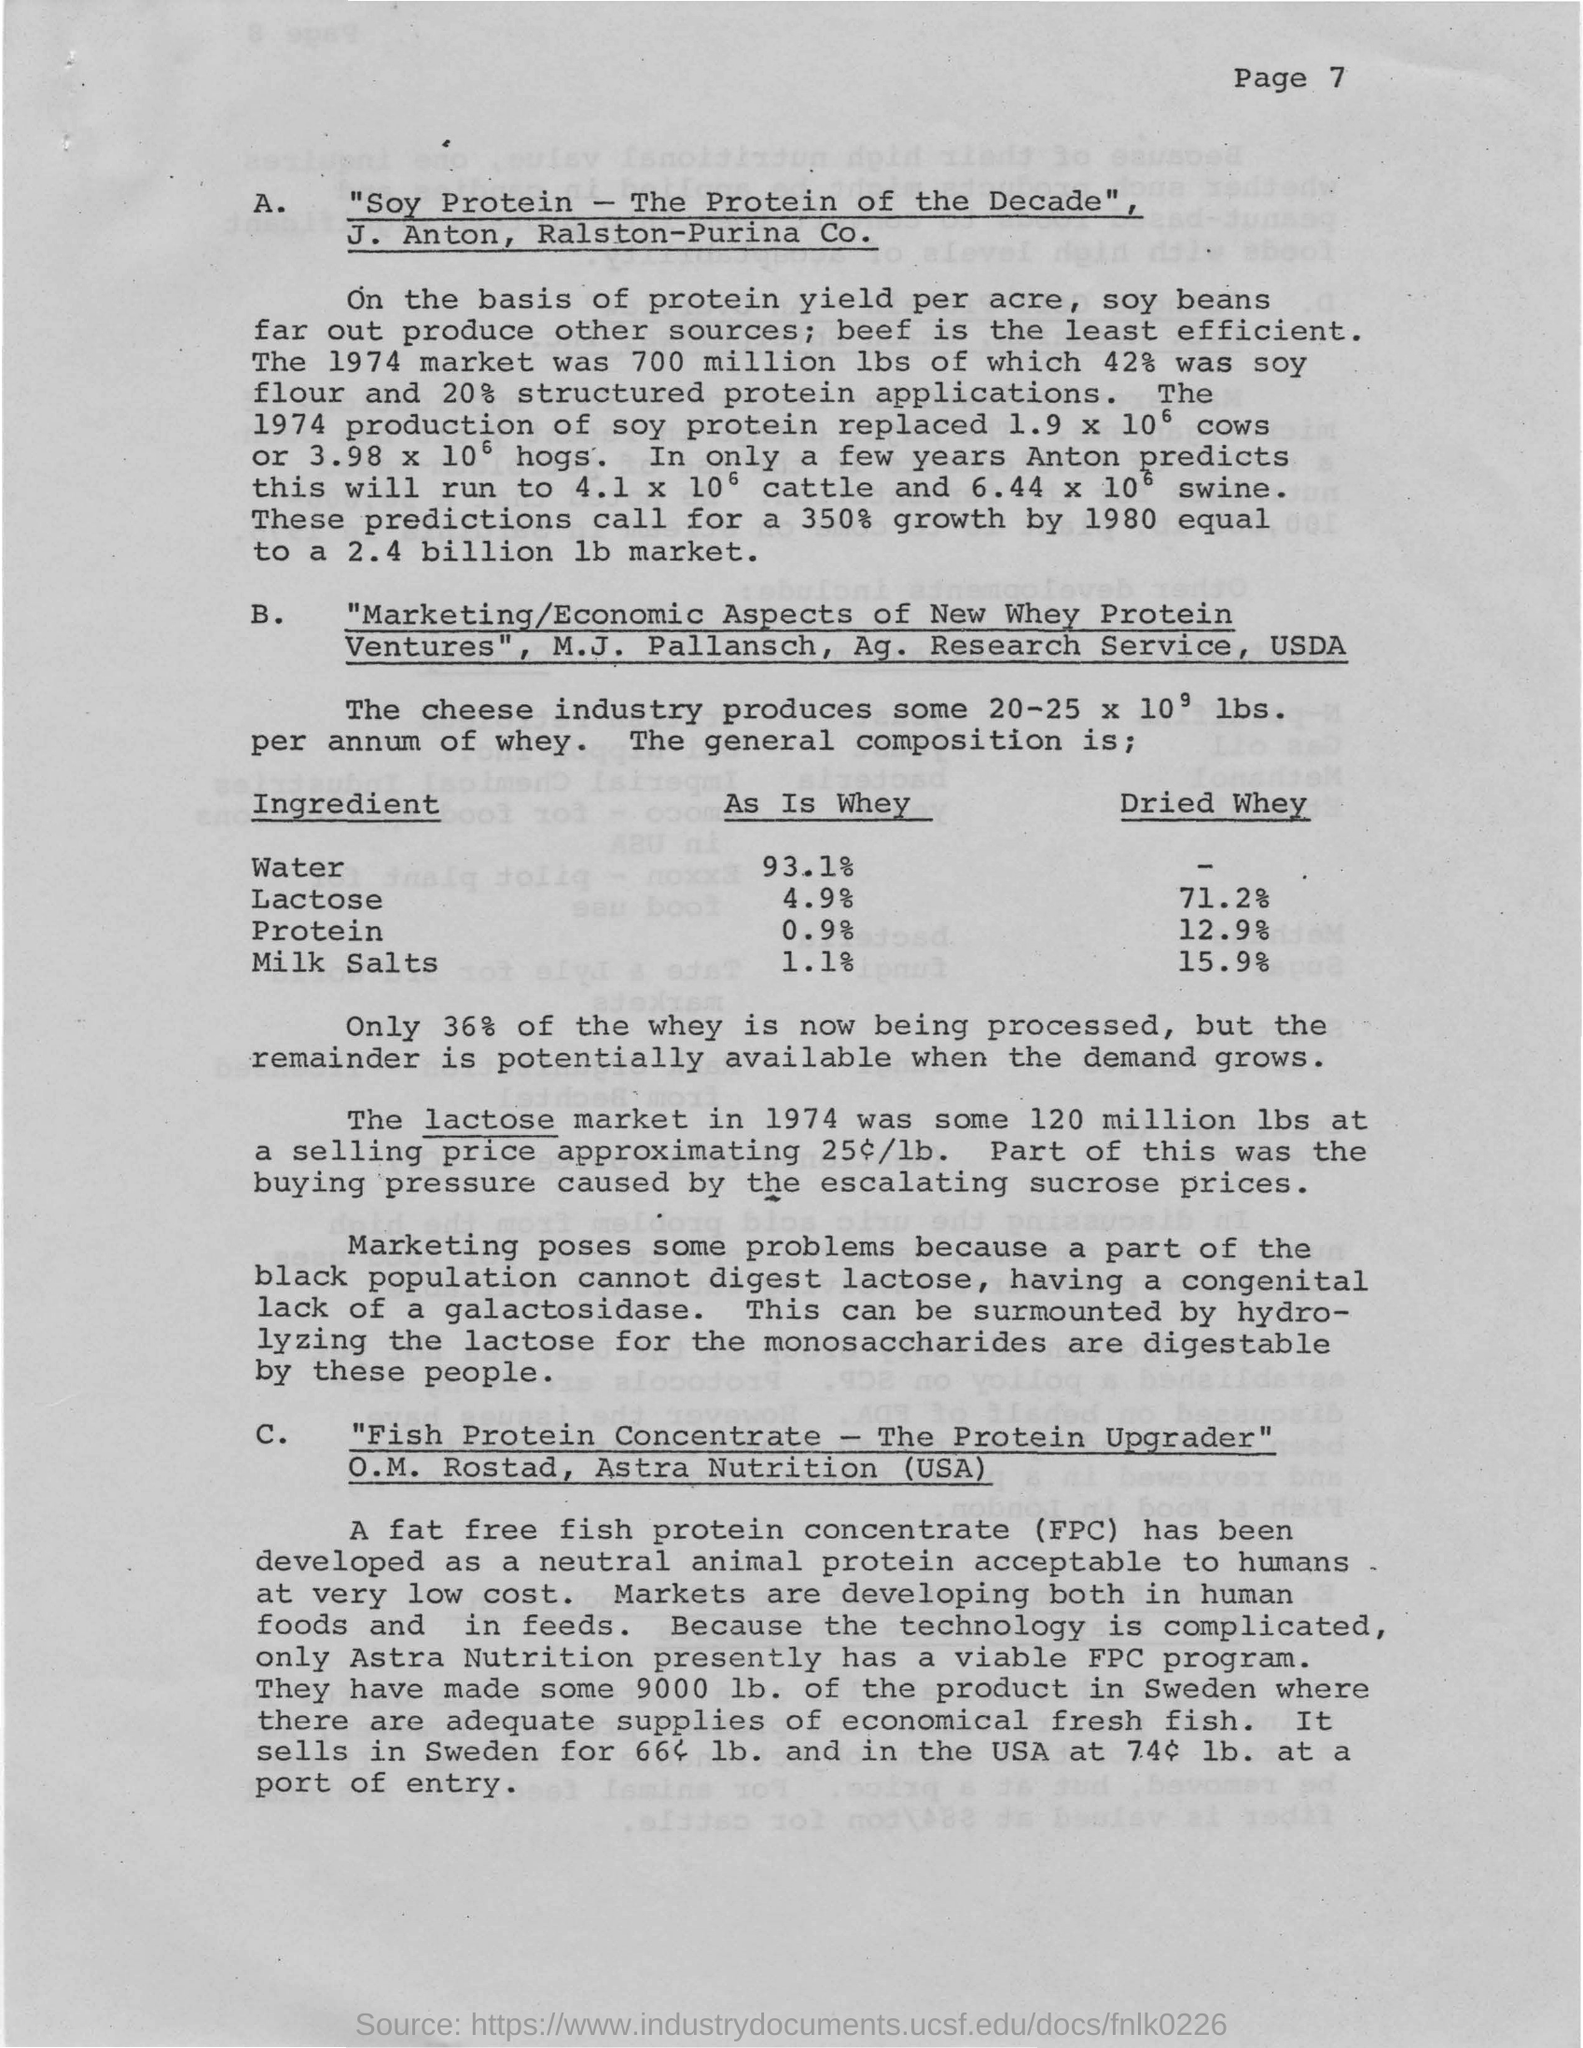What is the page number of the document?
Offer a very short reply. Page 7. 